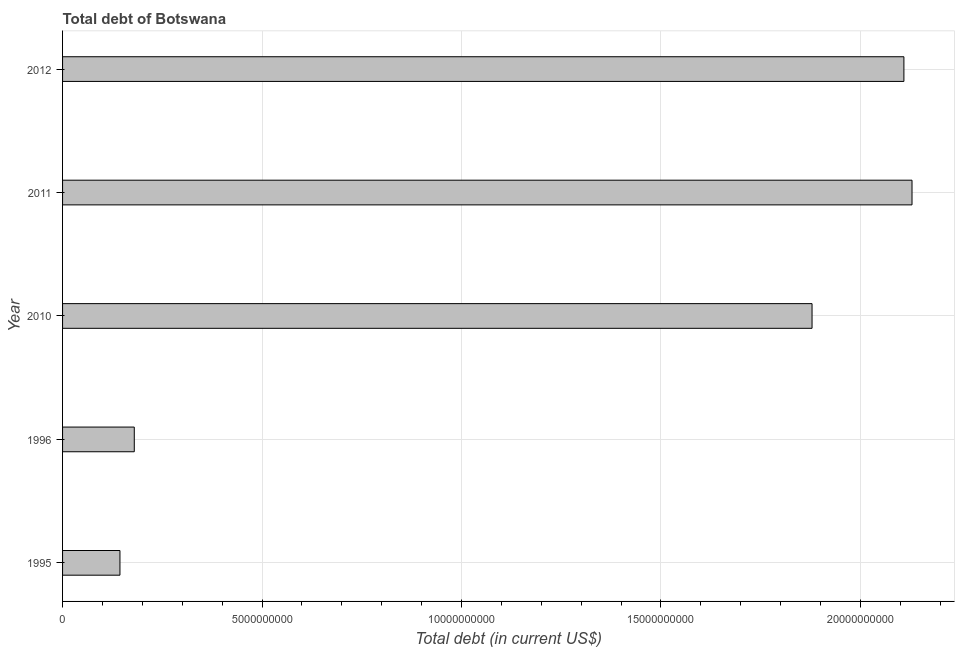What is the title of the graph?
Offer a very short reply. Total debt of Botswana. What is the label or title of the X-axis?
Give a very brief answer. Total debt (in current US$). What is the label or title of the Y-axis?
Provide a short and direct response. Year. What is the total debt in 2010?
Offer a very short reply. 1.88e+1. Across all years, what is the maximum total debt?
Ensure brevity in your answer.  2.13e+1. Across all years, what is the minimum total debt?
Give a very brief answer. 1.44e+09. In which year was the total debt minimum?
Provide a short and direct response. 1995. What is the sum of the total debt?
Provide a short and direct response. 6.44e+1. What is the difference between the total debt in 1996 and 2012?
Make the answer very short. -1.93e+1. What is the average total debt per year?
Offer a terse response. 1.29e+1. What is the median total debt?
Your answer should be compact. 1.88e+1. Do a majority of the years between 1995 and 2012 (inclusive) have total debt greater than 13000000000 US$?
Offer a terse response. Yes. What is the ratio of the total debt in 1996 to that in 2011?
Offer a terse response. 0.08. Is the total debt in 2010 less than that in 2012?
Offer a terse response. Yes. What is the difference between the highest and the second highest total debt?
Offer a very short reply. 2.03e+08. What is the difference between the highest and the lowest total debt?
Keep it short and to the point. 1.99e+1. In how many years, is the total debt greater than the average total debt taken over all years?
Give a very brief answer. 3. How many years are there in the graph?
Provide a short and direct response. 5. What is the Total debt (in current US$) in 1995?
Provide a short and direct response. 1.44e+09. What is the Total debt (in current US$) of 1996?
Your answer should be very brief. 1.80e+09. What is the Total debt (in current US$) in 2010?
Make the answer very short. 1.88e+1. What is the Total debt (in current US$) of 2011?
Make the answer very short. 2.13e+1. What is the Total debt (in current US$) of 2012?
Ensure brevity in your answer.  2.11e+1. What is the difference between the Total debt (in current US$) in 1995 and 1996?
Provide a short and direct response. -3.59e+08. What is the difference between the Total debt (in current US$) in 1995 and 2010?
Your response must be concise. -1.74e+1. What is the difference between the Total debt (in current US$) in 1995 and 2011?
Keep it short and to the point. -1.99e+1. What is the difference between the Total debt (in current US$) in 1995 and 2012?
Offer a terse response. -1.97e+1. What is the difference between the Total debt (in current US$) in 1996 and 2010?
Provide a succinct answer. -1.70e+1. What is the difference between the Total debt (in current US$) in 1996 and 2011?
Offer a terse response. -1.95e+1. What is the difference between the Total debt (in current US$) in 1996 and 2012?
Give a very brief answer. -1.93e+1. What is the difference between the Total debt (in current US$) in 2010 and 2011?
Ensure brevity in your answer.  -2.51e+09. What is the difference between the Total debt (in current US$) in 2010 and 2012?
Provide a succinct answer. -2.30e+09. What is the difference between the Total debt (in current US$) in 2011 and 2012?
Provide a succinct answer. 2.03e+08. What is the ratio of the Total debt (in current US$) in 1995 to that in 1996?
Give a very brief answer. 0.8. What is the ratio of the Total debt (in current US$) in 1995 to that in 2010?
Your response must be concise. 0.08. What is the ratio of the Total debt (in current US$) in 1995 to that in 2011?
Offer a very short reply. 0.07. What is the ratio of the Total debt (in current US$) in 1995 to that in 2012?
Provide a short and direct response. 0.07. What is the ratio of the Total debt (in current US$) in 1996 to that in 2010?
Your answer should be compact. 0.1. What is the ratio of the Total debt (in current US$) in 1996 to that in 2011?
Keep it short and to the point. 0.08. What is the ratio of the Total debt (in current US$) in 1996 to that in 2012?
Your answer should be very brief. 0.09. What is the ratio of the Total debt (in current US$) in 2010 to that in 2011?
Give a very brief answer. 0.88. What is the ratio of the Total debt (in current US$) in 2010 to that in 2012?
Offer a very short reply. 0.89. 